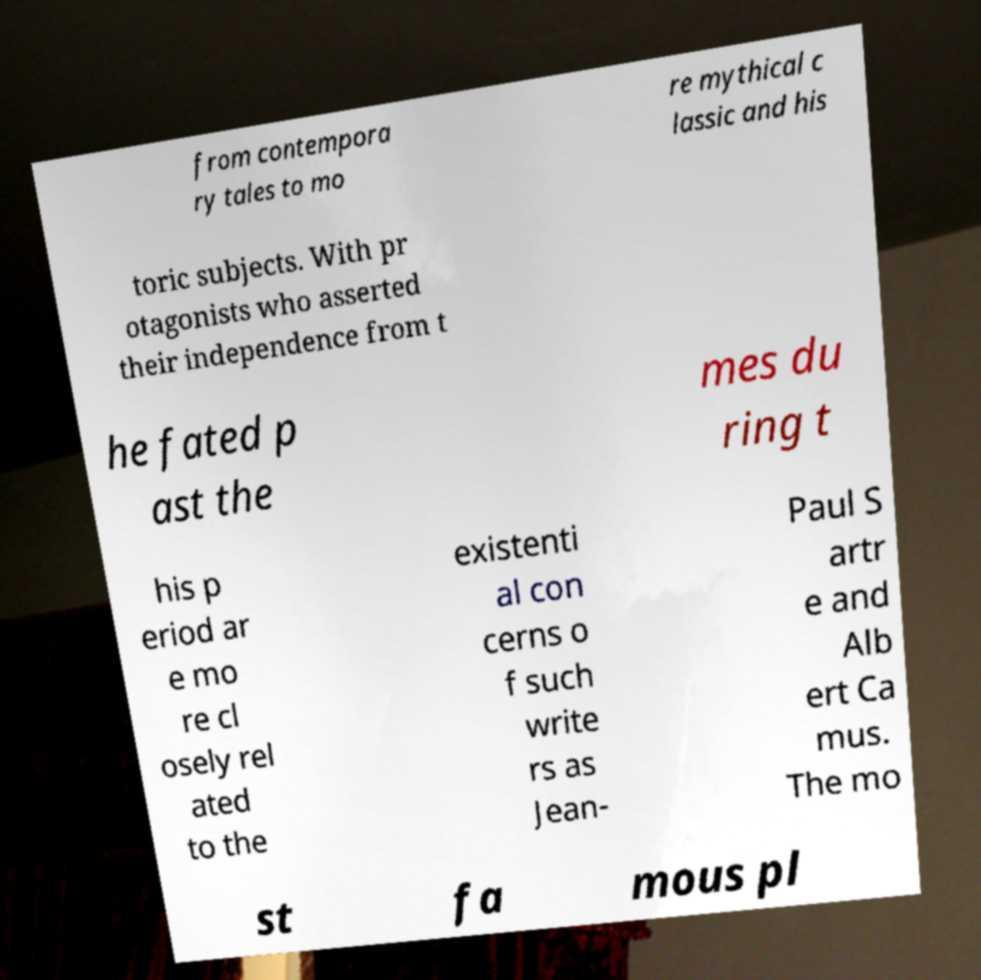What messages or text are displayed in this image? I need them in a readable, typed format. from contempora ry tales to mo re mythical c lassic and his toric subjects. With pr otagonists who asserted their independence from t he fated p ast the mes du ring t his p eriod ar e mo re cl osely rel ated to the existenti al con cerns o f such write rs as Jean- Paul S artr e and Alb ert Ca mus. The mo st fa mous pl 